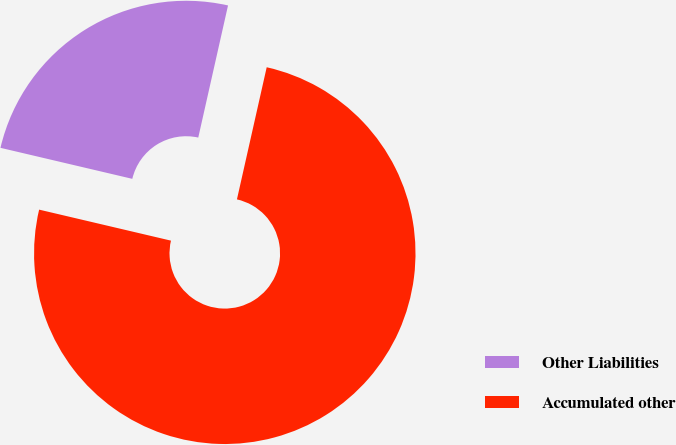Convert chart to OTSL. <chart><loc_0><loc_0><loc_500><loc_500><pie_chart><fcel>Other Liabilities<fcel>Accumulated other<nl><fcel>24.85%<fcel>75.15%<nl></chart> 